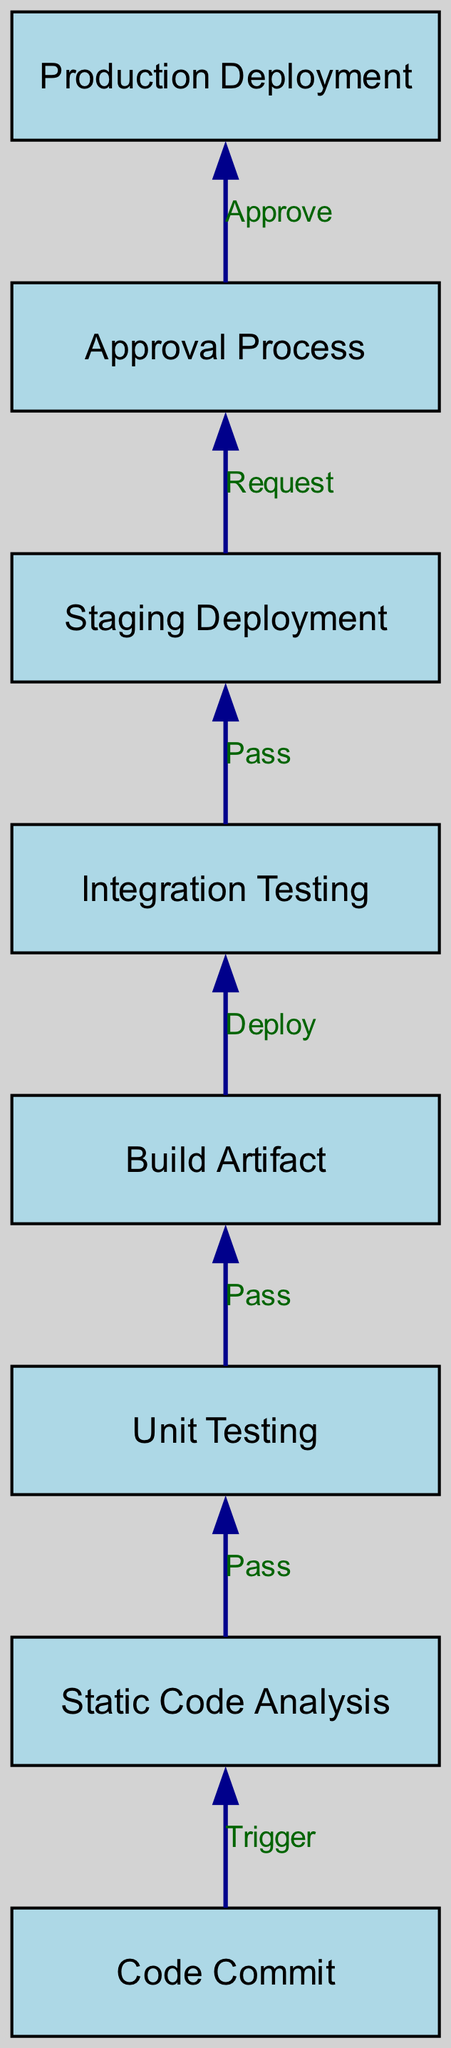What is the starting point of the CI/CD pipeline? The diagram begins with the node labeled "Code Commit," which is the initial stage of the CI/CD pipeline.
Answer: Code Commit How many nodes are there in the CI/CD pipeline? By counting the number of individual nodes represented in the diagram, we find a total of eight nodes.
Answer: Eight What is the relationship between "Static Code Analysis" and "Unit Testing"? The edge connecting "Static Code Analysis" and "Unit Testing" is labeled "Pass," indicating that if the static code analysis is successful, it triggers unit testing to occur next.
Answer: Pass What is the connection between "Integration Testing" and "Staging Deployment"? The edge between "Integration Testing" and "Staging Deployment" is labeled "Pass," meaning that when integration testing is successful, it leads directly to staging deployment.
Answer: Pass How many edges are there in the diagram? By counting all the directed edges that illustrate the flow between the nodes, we identify a total of seven edges.
Answer: Seven What is the last stage before production deployment? The diagram shows that the stage prior to production deployment is the "Approval Process," where approvals are required before moving to the final stage.
Answer: Approval Process What happens after "Staging Deployment" if it is successful? If "Staging Deployment" is successful, it leads to the "Approval Process" as indicated by the edge labeled "Request."
Answer: Approval Process What is the final action in the CI/CD pipeline? The last action depicted in the diagram is the "Production Deployment," which is the final step in the CI/CD process.
Answer: Production Deployment 